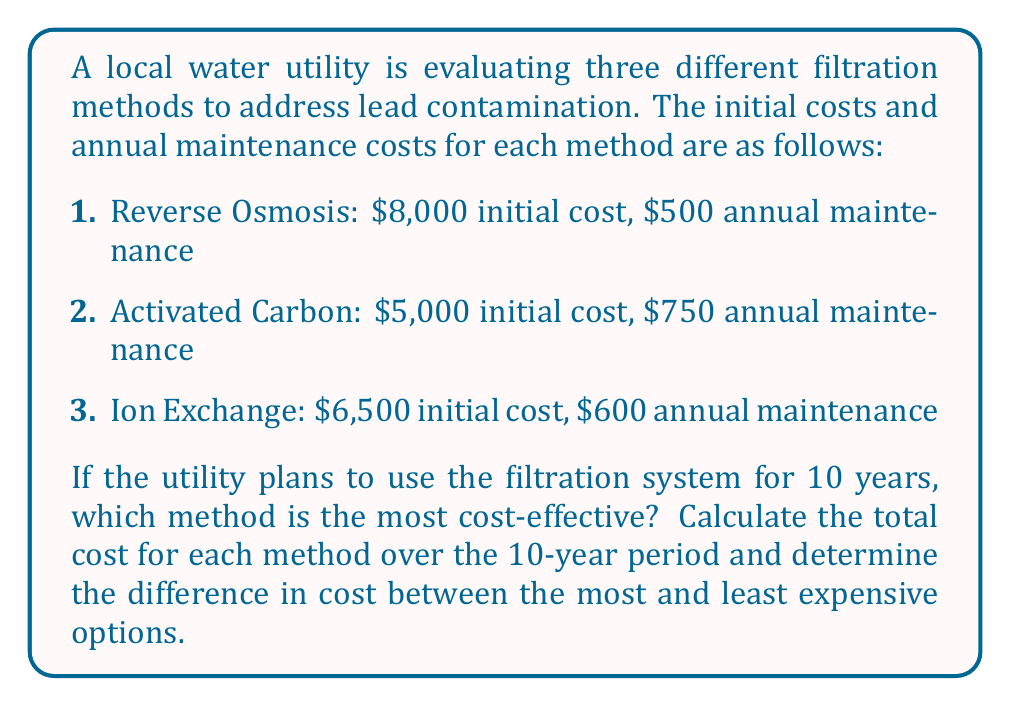Provide a solution to this math problem. To solve this problem, we need to calculate the total cost for each filtration method over a 10-year period. The total cost includes the initial cost plus the annual maintenance cost multiplied by the number of years.

Let's calculate the cost for each method:

1. Reverse Osmosis:
   Total Cost = Initial Cost + (Annual Maintenance × Number of Years)
   $$\text{Total Cost}_{\text{RO}} = 8000 + (500 \times 10) = 8000 + 5000 = 13000$$

2. Activated Carbon:
   $$\text{Total Cost}_{\text{AC}} = 5000 + (750 \times 10) = 5000 + 7500 = 12500$$

3. Ion Exchange:
   $$\text{Total Cost}_{\text{IE}} = 6500 + (600 \times 10) = 6500 + 6000 = 12500$$

To determine the most cost-effective method, we compare the total costs:

Reverse Osmosis: $13,000
Activated Carbon: $12,500
Ion Exchange: $12,500

The most cost-effective methods are Activated Carbon and Ion Exchange, both costing $12,500 over 10 years.

To find the difference between the most and least expensive options:

$$\text{Difference} = \text{Most Expensive} - \text{Least Expensive} = 13000 - 12500 = 500$$
Answer: The most cost-effective filtration methods are Activated Carbon and Ion Exchange, both costing $12,500 over 10 years. The difference in cost between the most expensive (Reverse Osmosis) and least expensive options is $500. 